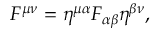<formula> <loc_0><loc_0><loc_500><loc_500>F ^ { \mu \nu } = \eta ^ { \mu \alpha } F _ { \alpha \beta } \eta ^ { \beta \nu } ,</formula> 